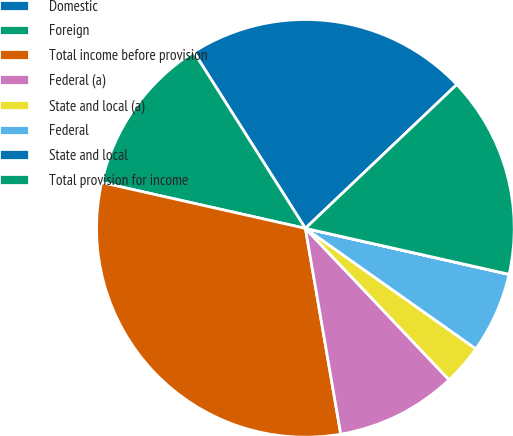<chart> <loc_0><loc_0><loc_500><loc_500><pie_chart><fcel>Domestic<fcel>Foreign<fcel>Total income before provision<fcel>Federal (a)<fcel>State and local (a)<fcel>Federal<fcel>State and local<fcel>Total provision for income<nl><fcel>21.89%<fcel>12.5%<fcel>31.23%<fcel>9.37%<fcel>3.13%<fcel>6.25%<fcel>0.01%<fcel>15.62%<nl></chart> 